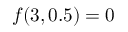Convert formula to latex. <formula><loc_0><loc_0><loc_500><loc_500>f ( 3 , 0 . 5 ) = 0</formula> 